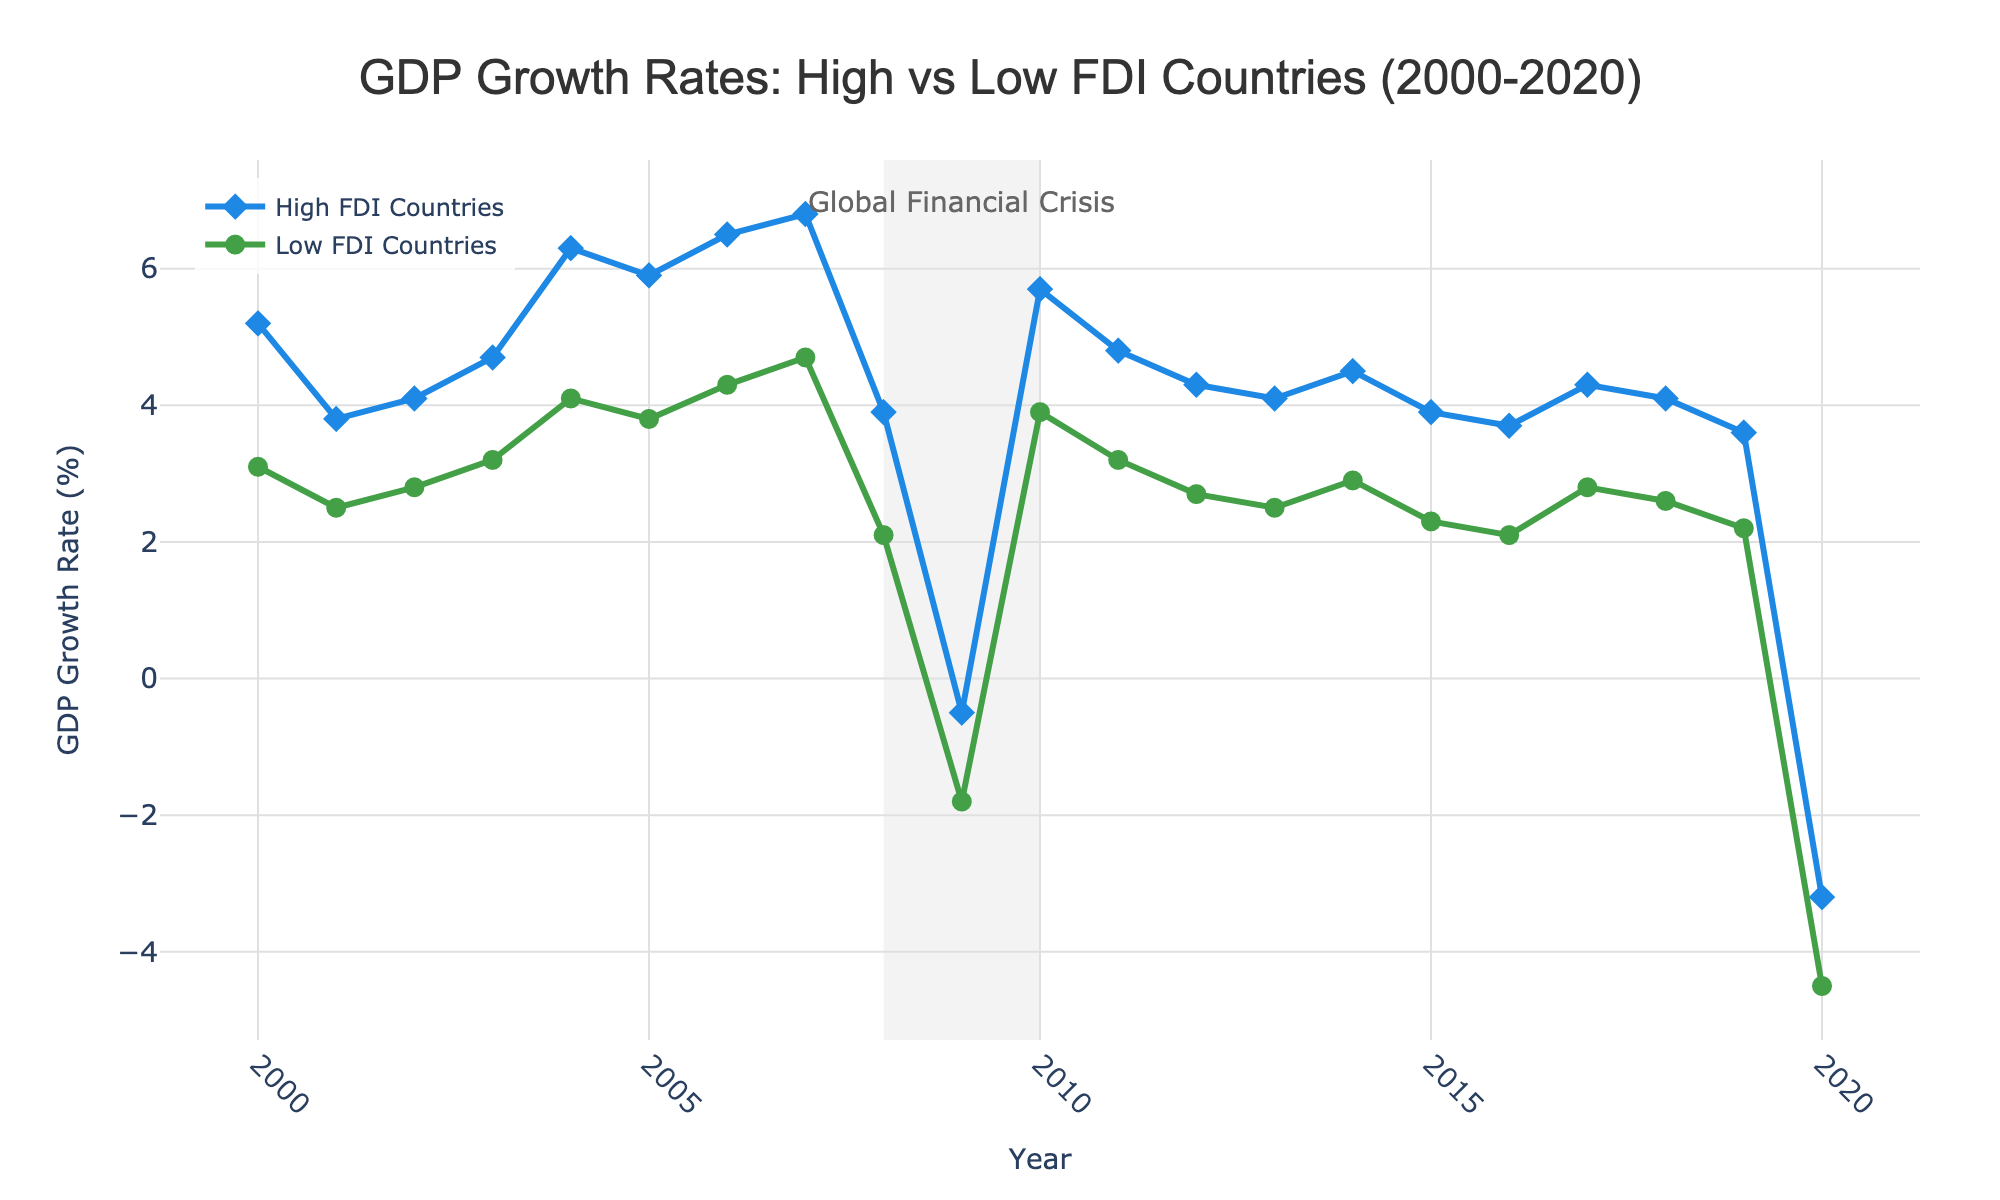What's the average GDP growth rate of High FDI Countries from 2008 to 2010? First, identify the GDP growth rates for High FDI Countries for the years 2008, 2009, and 2010, which are 3.9, -0.5, and 5.7 respectively. Sum these values: 3.9 + (-0.5) + 5.7 = 9.1. Then, divide by the number of years (3) to get the average: 9.1 / 3 = 3.03
Answer: 3.03 Which year between 2000 and 2020 did Low FDI Countries experience the lowest GDP growth rate? Look at the GDP growth rates for Low FDI Countries from 2000 to 2020 and identify the lowest value, which is -4.5 in 2020.
Answer: 2020 How did the GDP growth rate of High FDI Countries compare to Low FDI Countries during the global financial crisis period (2008-2010)? For High FDI Countries, the growth rates for 2008, 2009, and 2010 were 3.9, -0.5, and 5.7 respectively. For Low FDI Countries, they were 2.1, -1.8, and 3.9. High FDI Countries experienced higher growth rates than Low FDI Countries in each of these years.
Answer: Higher What is the difference between the highest GDP growth rate of High FDI Countries and Low FDI Countries throughout the entire period? The highest GDP growth rate for High FDI Countries is 6.8 in 2007. For Low FDI Countries, it is 4.7 in 2007. The difference is 6.8 - 4.7 = 2.1
Answer: 2.1 During which year(s) did both High and Low FDI Countries experience negative GDP growth rates? Identify the years where both High and Low FDI Countries have negative GDP growth rates. They are only negative in 2009 (High FDI: -0.5, Low FDI: -1.8) and 2020 (High FDI: -3.2, Low FDI: -4.5).
Answer: 2009, 2020 What is the overall trend of GDP growth rates for High FDI Countries from 2000 to 2020? Review the GDP growth rates for High FDI Countries from 2000 to 2020. The rates initially increase, peak around 2007, decrease during the financial crisis, recover, and then decline slightly towards 2020. The overall trend shows fluctuations with a general increasing then decreasing pattern.
Answer: Fluctuating Compare the GDP growth rate change from 2019 to 2020 for High FDI Countries and Low FDI Countries. The GDP growth rate for High FDI Countries changed from 3.6 in 2019 to -3.2 in 2020, a decrease of 3.6 - (-3.2) = 6.8. For Low FDI Countries, it changed from 2.2 in 2019 to -4.5 in 2020, a decrease of 2.2 - (-4.5) = 6.7. Both experienced similar decreases.
Answer: Similar decrease What can be inferred about the impact of the global financial crisis on High and Low FDI Countries based on the shaded area in the plot? The shaded area from 2008 to 2010 indicates the global financial crisis. Both High and Low FDI Countries show a significant dip in GDP growth rates. High FDI Countries' rates drop but recover more rapidly in 2010, whereas Low FDI Countries took longer to recover fully.
Answer: Significant negative impact, quicker recovery for High FDI What visual attribute indicates the global financial crisis in the plot? There is a shaded area in the plot from 2008 to 2010 labeled "Global Financial Crisis." This visual attribute highlights this critical period.
Answer: Shaded area 